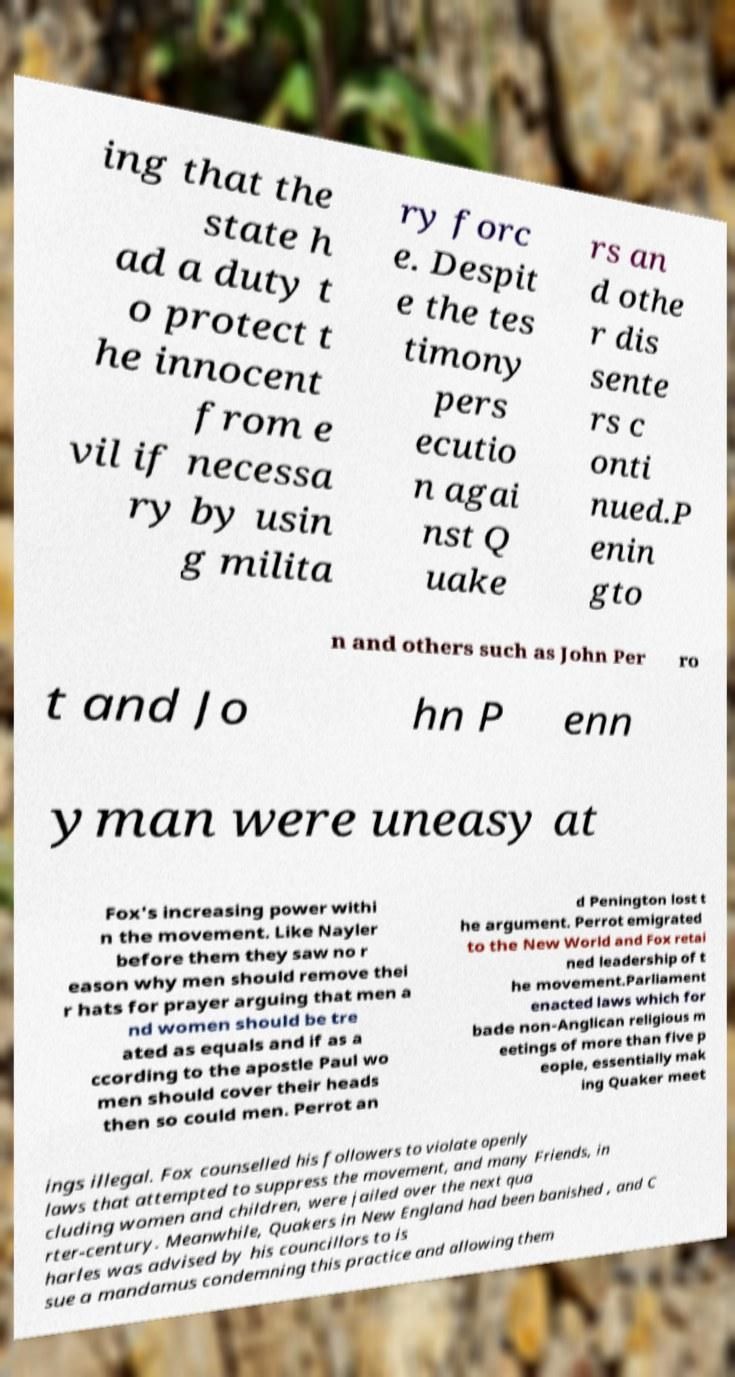Please read and relay the text visible in this image. What does it say? ing that the state h ad a duty t o protect t he innocent from e vil if necessa ry by usin g milita ry forc e. Despit e the tes timony pers ecutio n agai nst Q uake rs an d othe r dis sente rs c onti nued.P enin gto n and others such as John Per ro t and Jo hn P enn yman were uneasy at Fox's increasing power withi n the movement. Like Nayler before them they saw no r eason why men should remove thei r hats for prayer arguing that men a nd women should be tre ated as equals and if as a ccording to the apostle Paul wo men should cover their heads then so could men. Perrot an d Penington lost t he argument. Perrot emigrated to the New World and Fox retai ned leadership of t he movement.Parliament enacted laws which for bade non-Anglican religious m eetings of more than five p eople, essentially mak ing Quaker meet ings illegal. Fox counselled his followers to violate openly laws that attempted to suppress the movement, and many Friends, in cluding women and children, were jailed over the next qua rter-century. Meanwhile, Quakers in New England had been banished , and C harles was advised by his councillors to is sue a mandamus condemning this practice and allowing them 